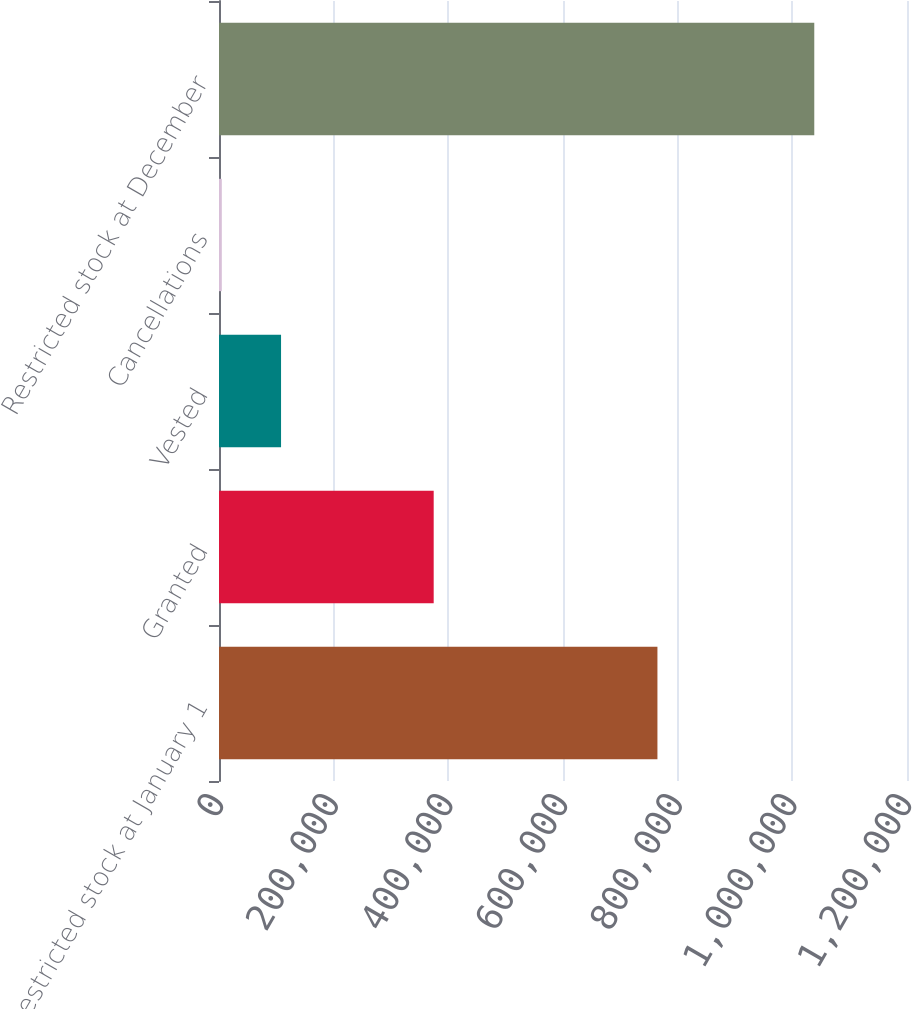Convert chart to OTSL. <chart><loc_0><loc_0><loc_500><loc_500><bar_chart><fcel>Restricted stock at January 1<fcel>Granted<fcel>Vested<fcel>Cancellations<fcel>Restricted stock at December<nl><fcel>764705<fcel>374455<fcel>108232<fcel>4895<fcel>1.03827e+06<nl></chart> 